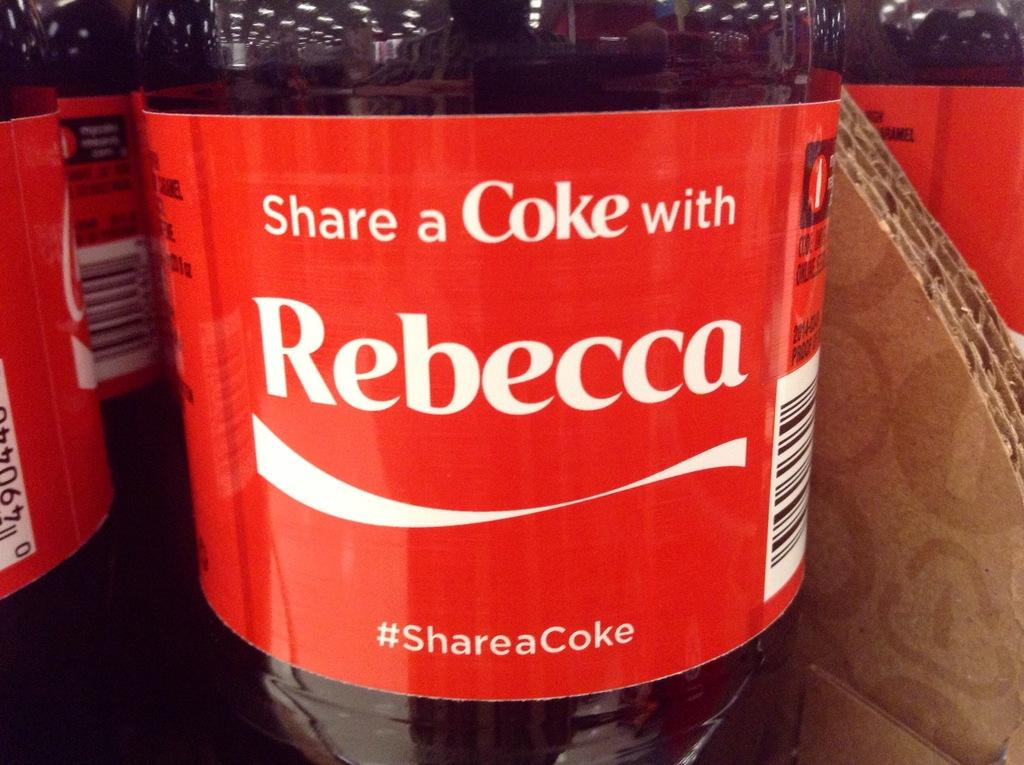<image>
Give a short and clear explanation of the subsequent image. bottles of coke, front one has the name rebecca on it 